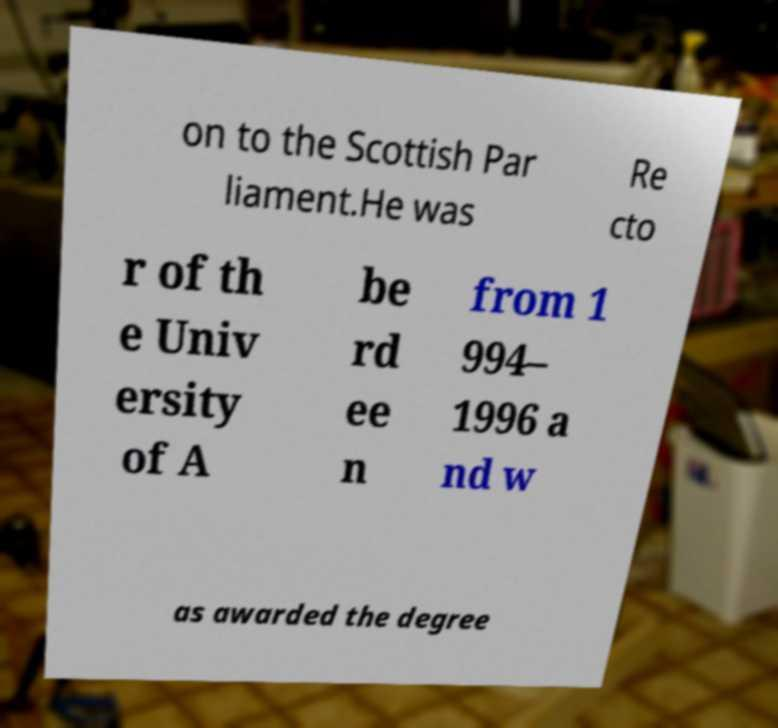Could you assist in decoding the text presented in this image and type it out clearly? on to the Scottish Par liament.He was Re cto r of th e Univ ersity of A be rd ee n from 1 994– 1996 a nd w as awarded the degree 